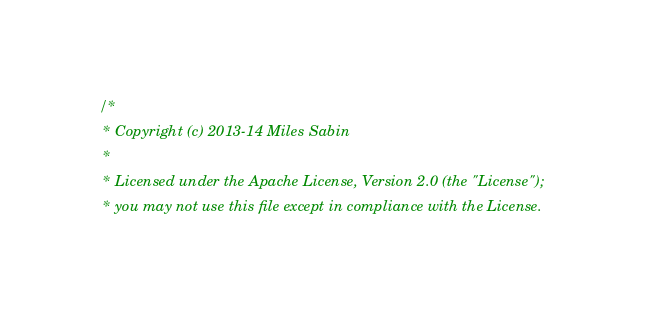Convert code to text. <code><loc_0><loc_0><loc_500><loc_500><_Scala_>/*
 * Copyright (c) 2013-14 Miles Sabin 
 *
 * Licensed under the Apache License, Version 2.0 (the "License");
 * you may not use this file except in compliance with the License.</code> 